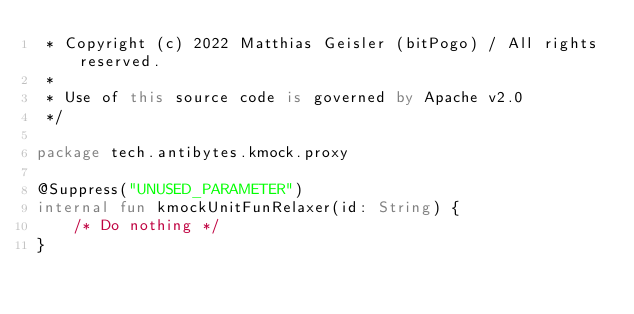<code> <loc_0><loc_0><loc_500><loc_500><_Kotlin_> * Copyright (c) 2022 Matthias Geisler (bitPogo) / All rights reserved.
 *
 * Use of this source code is governed by Apache v2.0
 */

package tech.antibytes.kmock.proxy

@Suppress("UNUSED_PARAMETER")
internal fun kmockUnitFunRelaxer(id: String) {
    /* Do nothing */
}
</code> 